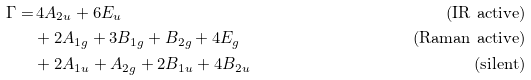<formula> <loc_0><loc_0><loc_500><loc_500>\Gamma = & \, 4 A _ { 2 u } + 6 E _ { u } & \text {(IR active)} \\ & + 2 A _ { 1 g } + 3 B _ { 1 g } + B _ { 2 g } + 4 E _ { g } & \text {(Raman active)} \\ & + 2 A _ { 1 u } + A _ { 2 g } + 2 B _ { 1 u } + 4 B _ { 2 u } & \text {(silent)}</formula> 